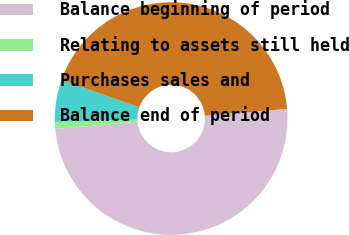<chart> <loc_0><loc_0><loc_500><loc_500><pie_chart><fcel>Balance beginning of period<fcel>Relating to assets still held<fcel>Purchases sales and<fcel>Balance end of period<nl><fcel>49.87%<fcel>0.97%<fcel>5.86%<fcel>43.3%<nl></chart> 